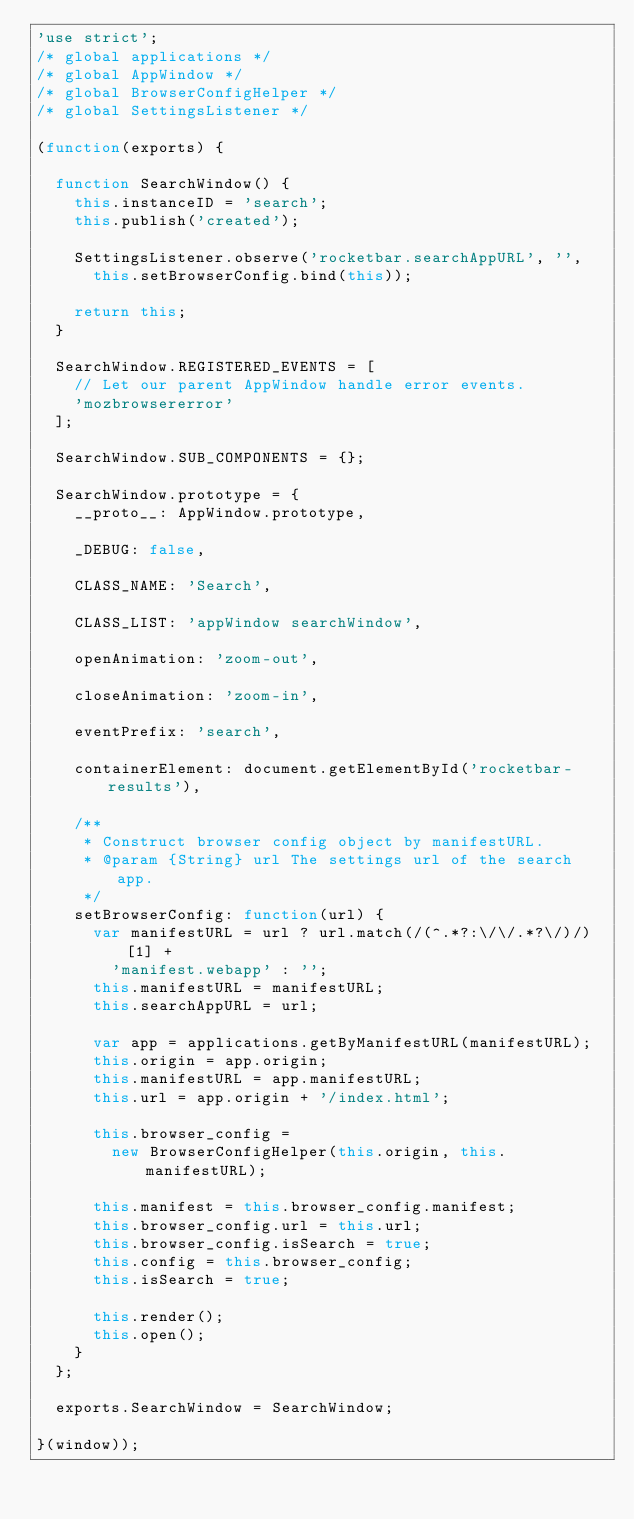Convert code to text. <code><loc_0><loc_0><loc_500><loc_500><_JavaScript_>'use strict';
/* global applications */
/* global AppWindow */
/* global BrowserConfigHelper */
/* global SettingsListener */

(function(exports) {

  function SearchWindow() {
    this.instanceID = 'search';
    this.publish('created');

    SettingsListener.observe('rocketbar.searchAppURL', '',
      this.setBrowserConfig.bind(this));

    return this;
  }

  SearchWindow.REGISTERED_EVENTS = [
    // Let our parent AppWindow handle error events.
    'mozbrowsererror'
  ];

  SearchWindow.SUB_COMPONENTS = {};

  SearchWindow.prototype = {
    __proto__: AppWindow.prototype,

    _DEBUG: false,

    CLASS_NAME: 'Search',

    CLASS_LIST: 'appWindow searchWindow',

    openAnimation: 'zoom-out',

    closeAnimation: 'zoom-in',

    eventPrefix: 'search',

    containerElement: document.getElementById('rocketbar-results'),

    /**
     * Construct browser config object by manifestURL.
     * @param {String} url The settings url of the search app.
     */
    setBrowserConfig: function(url) {
      var manifestURL = url ? url.match(/(^.*?:\/\/.*?\/)/)[1] +
        'manifest.webapp' : '';
      this.manifestURL = manifestURL;
      this.searchAppURL = url;

      var app = applications.getByManifestURL(manifestURL);
      this.origin = app.origin;
      this.manifestURL = app.manifestURL;
      this.url = app.origin + '/index.html';

      this.browser_config =
        new BrowserConfigHelper(this.origin, this.manifestURL);

      this.manifest = this.browser_config.manifest;
      this.browser_config.url = this.url;
      this.browser_config.isSearch = true;
      this.config = this.browser_config;
      this.isSearch = true;

      this.render();
      this.open();
    }
  };

  exports.SearchWindow = SearchWindow;

}(window));
</code> 